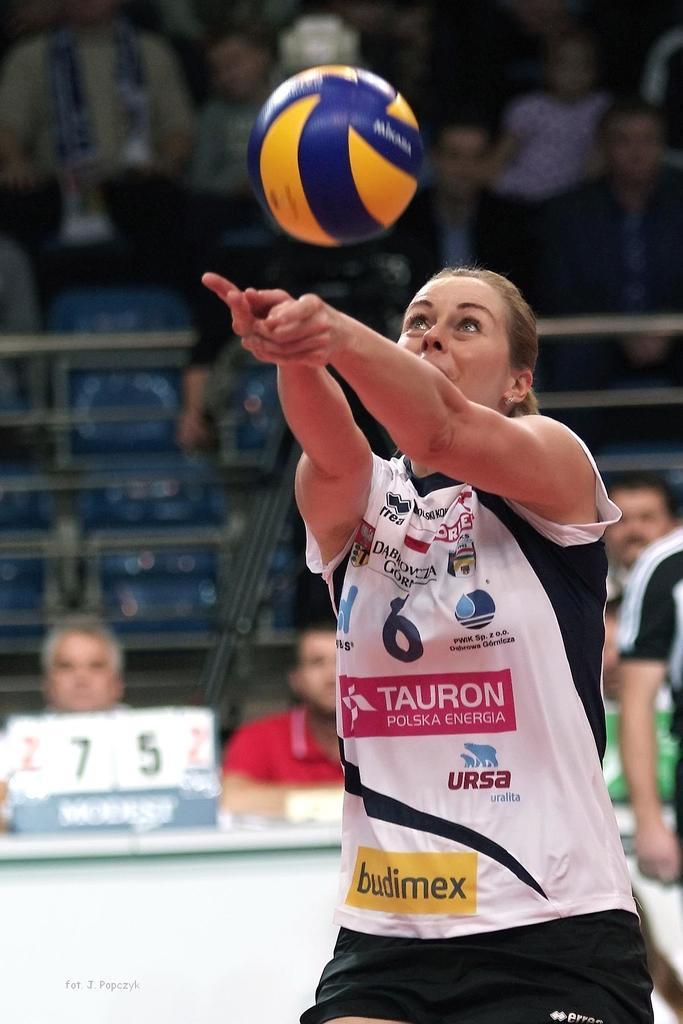Please provide a concise description of this image. This picture describes about group of people, few are seated and few are standing, on the right side of the image we can see a woman, in front of her we can see a ball, in the background we can see few metal rods. 